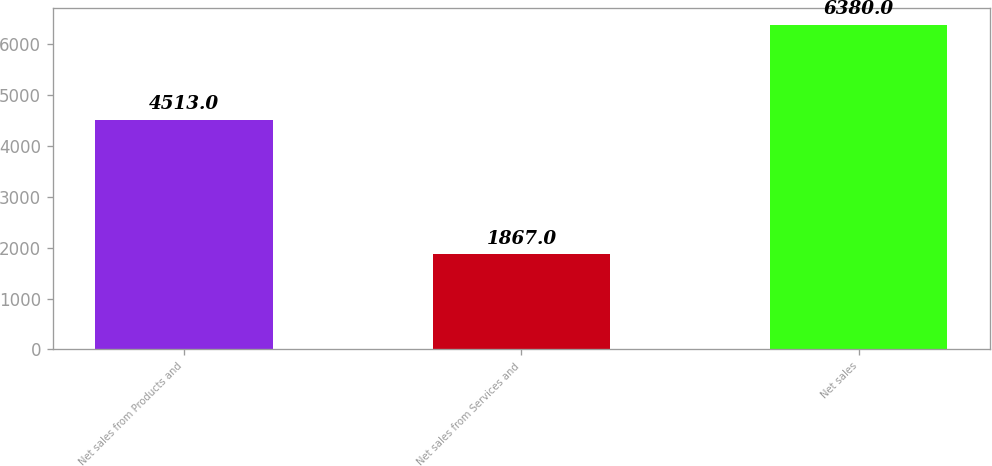<chart> <loc_0><loc_0><loc_500><loc_500><bar_chart><fcel>Net sales from Products and<fcel>Net sales from Services and<fcel>Net sales<nl><fcel>4513<fcel>1867<fcel>6380<nl></chart> 